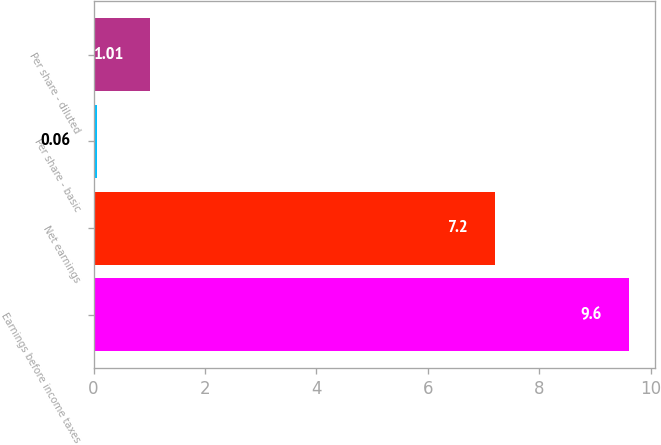Convert chart to OTSL. <chart><loc_0><loc_0><loc_500><loc_500><bar_chart><fcel>Earnings before income taxes<fcel>Net earnings<fcel>Per share - basic<fcel>Per share - diluted<nl><fcel>9.6<fcel>7.2<fcel>0.06<fcel>1.01<nl></chart> 